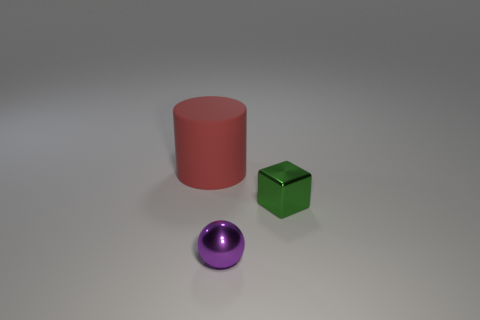What is the material of the ball that is the same size as the metal block?
Offer a very short reply. Metal. How many other objects are there of the same material as the red cylinder?
Give a very brief answer. 0. Are there the same number of metal things to the right of the tiny green block and metallic spheres that are right of the purple thing?
Provide a succinct answer. Yes. How many gray things are either rubber things or metal things?
Offer a very short reply. 0. Is the color of the sphere the same as the tiny shiny thing that is behind the purple metallic ball?
Make the answer very short. No. What number of other things are there of the same color as the rubber thing?
Provide a short and direct response. 0. Are there fewer blue rubber objects than green shiny blocks?
Provide a succinct answer. Yes. There is a shiny thing in front of the thing that is on the right side of the tiny metal ball; what number of red cylinders are in front of it?
Keep it short and to the point. 0. How big is the object that is to the right of the small purple metallic sphere?
Make the answer very short. Small. Does the small metallic thing that is to the left of the green shiny cube have the same shape as the red matte thing?
Your answer should be compact. No. 